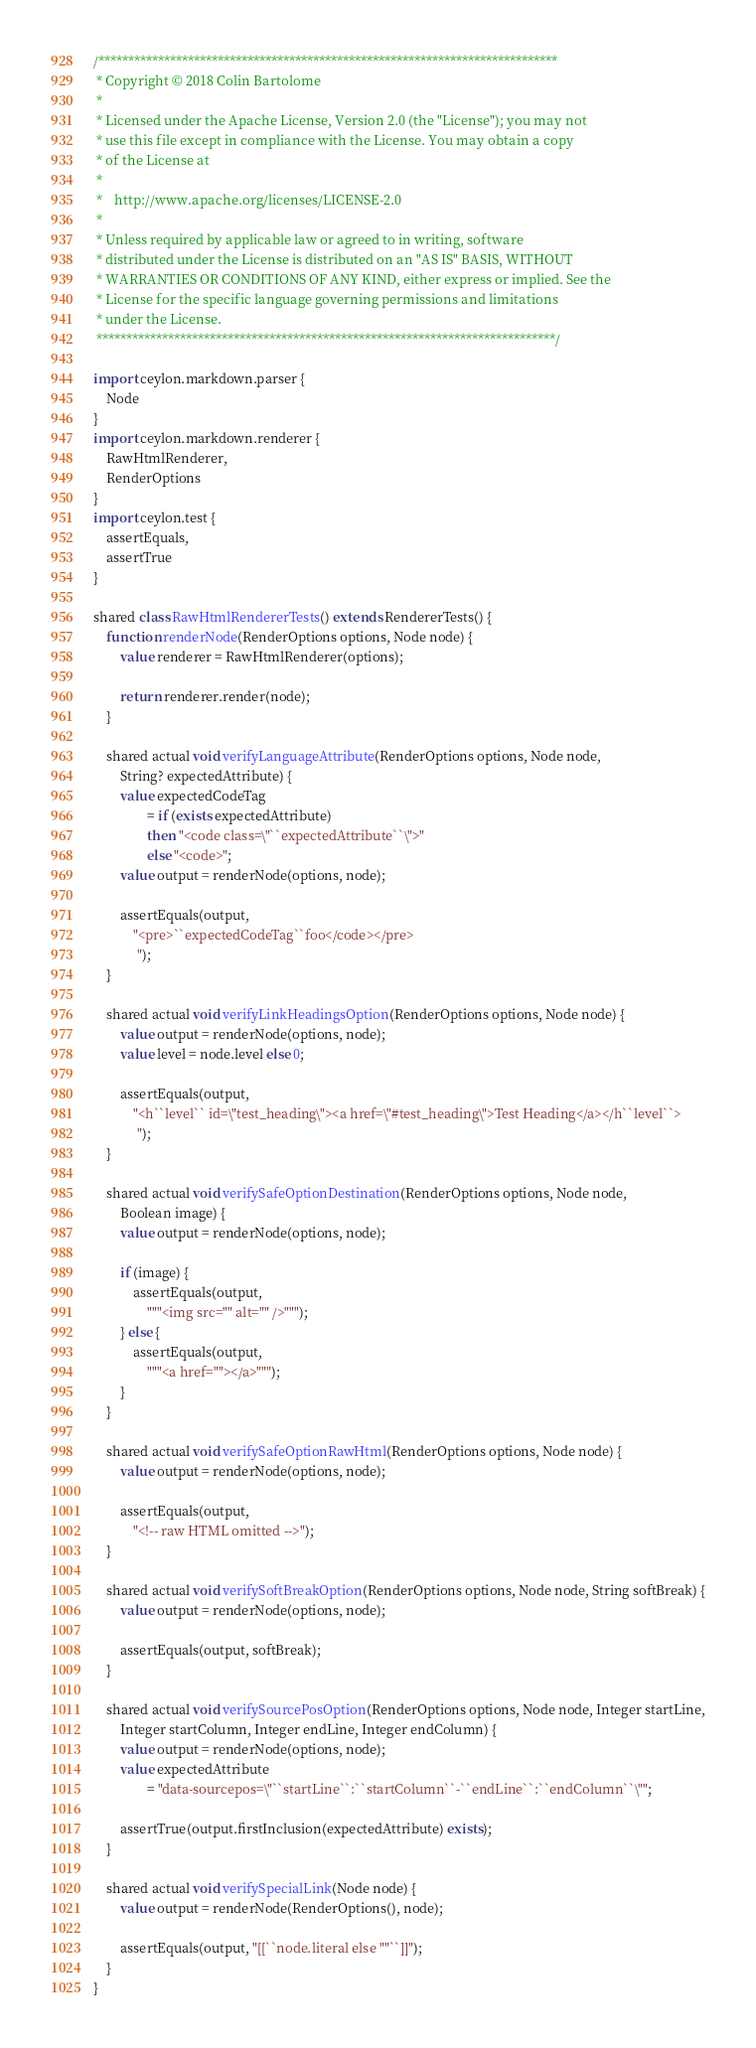<code> <loc_0><loc_0><loc_500><loc_500><_Ceylon_>/*****************************************************************************
 * Copyright © 2018 Colin Bartolome
 * 
 * Licensed under the Apache License, Version 2.0 (the "License"); you may not
 * use this file except in compliance with the License. You may obtain a copy
 * of the License at
 * 
 *    http://www.apache.org/licenses/LICENSE-2.0
 * 
 * Unless required by applicable law or agreed to in writing, software
 * distributed under the License is distributed on an "AS IS" BASIS, WITHOUT
 * WARRANTIES OR CONDITIONS OF ANY KIND, either express or implied. See the
 * License for the specific language governing permissions and limitations
 * under the License.
 *****************************************************************************/

import ceylon.markdown.parser {
    Node
}
import ceylon.markdown.renderer {
    RawHtmlRenderer,
    RenderOptions
}
import ceylon.test {
    assertEquals,
    assertTrue
}

shared class RawHtmlRendererTests() extends RendererTests() {
    function renderNode(RenderOptions options, Node node) {
        value renderer = RawHtmlRenderer(options);
        
        return renderer.render(node);
    }
    
    shared actual void verifyLanguageAttribute(RenderOptions options, Node node,
        String? expectedAttribute) {
        value expectedCodeTag
                = if (exists expectedAttribute)
                then "<code class=\"``expectedAttribute``\">"
                else "<code>";
        value output = renderNode(options, node);
        
        assertEquals(output,
            "<pre>``expectedCodeTag``foo</code></pre>
             ");
    }
    
    shared actual void verifyLinkHeadingsOption(RenderOptions options, Node node) {
        value output = renderNode(options, node);
        value level = node.level else 0;
        
        assertEquals(output,
            "<h``level`` id=\"test_heading\"><a href=\"#test_heading\">Test Heading</a></h``level``>
             ");
    }
    
    shared actual void verifySafeOptionDestination(RenderOptions options, Node node,
        Boolean image) {
        value output = renderNode(options, node);
        
        if (image) {
            assertEquals(output,
                """<img src="" alt="" />""");
        } else {
            assertEquals(output,
                """<a href=""></a>""");
        }
    }
    
    shared actual void verifySafeOptionRawHtml(RenderOptions options, Node node) {
        value output = renderNode(options, node);
        
        assertEquals(output,
            "<!-- raw HTML omitted -->");
    }
    
    shared actual void verifySoftBreakOption(RenderOptions options, Node node, String softBreak) {
        value output = renderNode(options, node);
        
        assertEquals(output, softBreak);
    }
    
    shared actual void verifySourcePosOption(RenderOptions options, Node node, Integer startLine,
        Integer startColumn, Integer endLine, Integer endColumn) {
        value output = renderNode(options, node);
        value expectedAttribute
                = "data-sourcepos=\"``startLine``:``startColumn``-``endLine``:``endColumn``\"";
        
        assertTrue(output.firstInclusion(expectedAttribute) exists);
    }
    
    shared actual void verifySpecialLink(Node node) {
        value output = renderNode(RenderOptions(), node);
        
        assertEquals(output, "[[``node.literal else ""``]]");
    }
}
</code> 